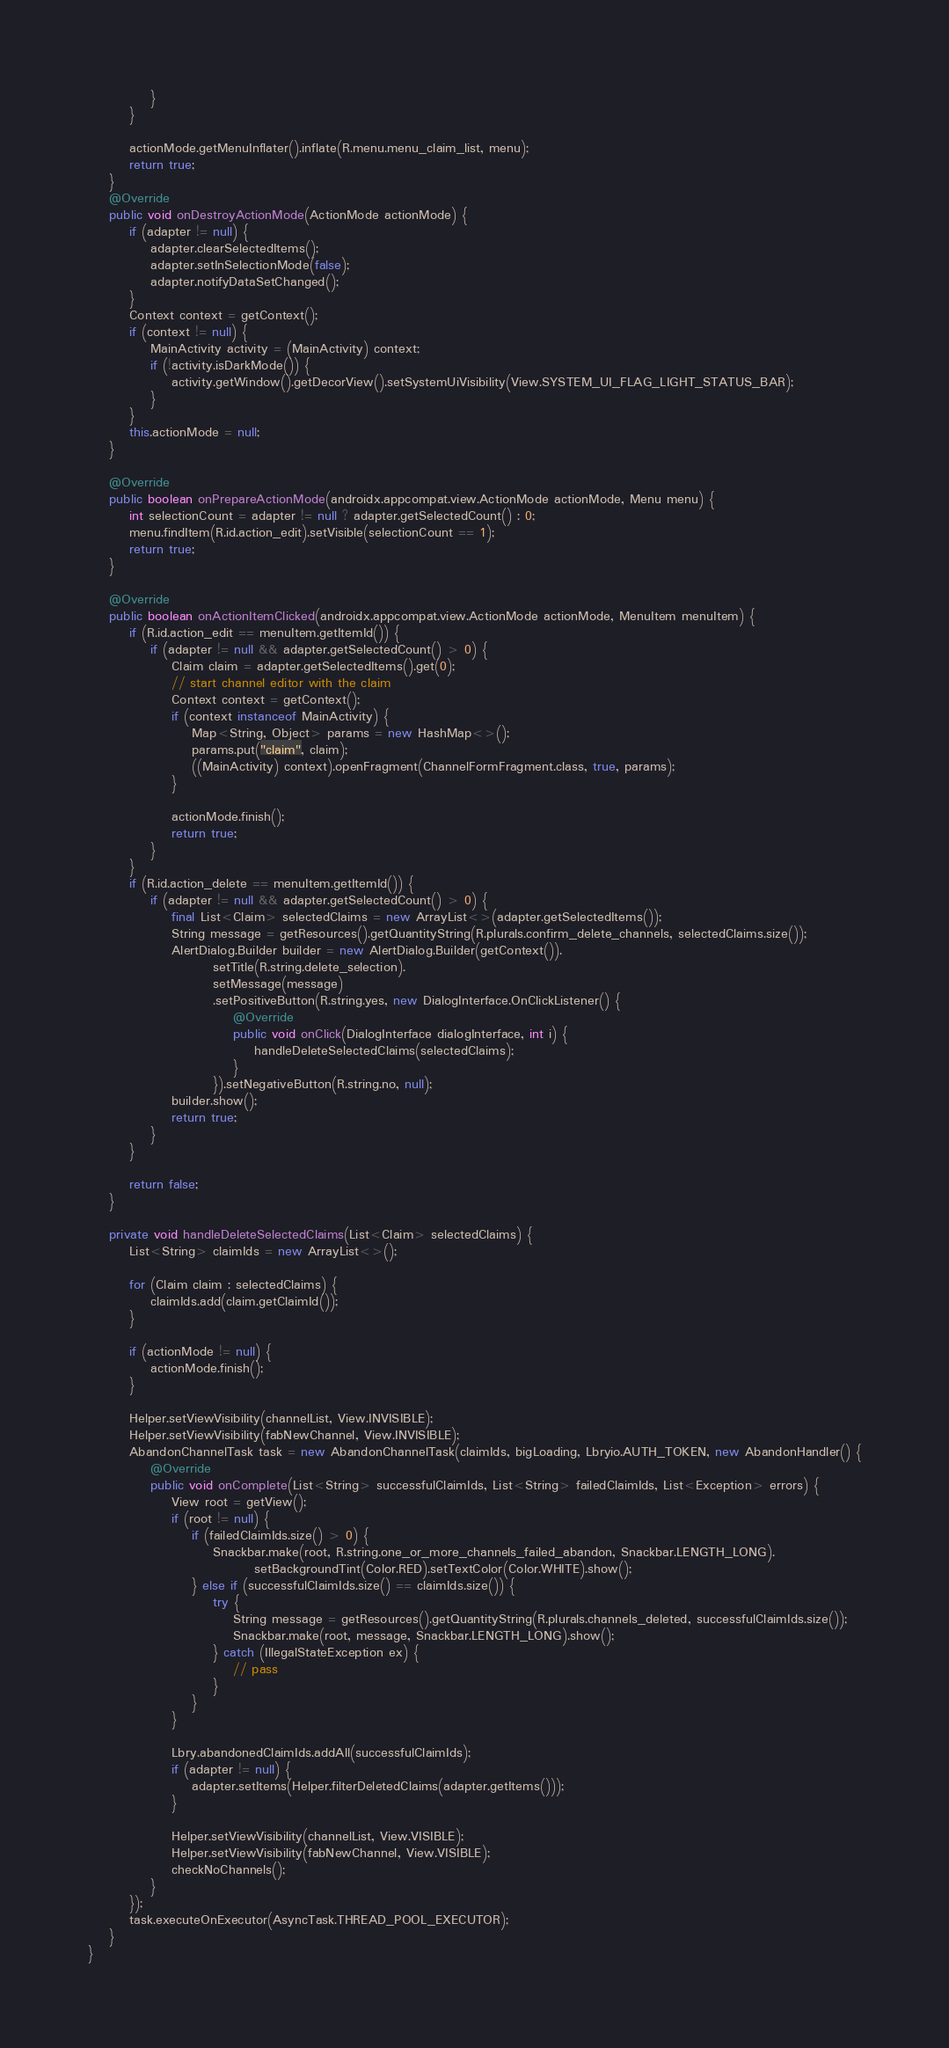<code> <loc_0><loc_0><loc_500><loc_500><_Java_>            }
        }

        actionMode.getMenuInflater().inflate(R.menu.menu_claim_list, menu);
        return true;
    }
    @Override
    public void onDestroyActionMode(ActionMode actionMode) {
        if (adapter != null) {
            adapter.clearSelectedItems();
            adapter.setInSelectionMode(false);
            adapter.notifyDataSetChanged();
        }
        Context context = getContext();
        if (context != null) {
            MainActivity activity = (MainActivity) context;
            if (!activity.isDarkMode()) {
                activity.getWindow().getDecorView().setSystemUiVisibility(View.SYSTEM_UI_FLAG_LIGHT_STATUS_BAR);
            }
        }
        this.actionMode = null;
    }

    @Override
    public boolean onPrepareActionMode(androidx.appcompat.view.ActionMode actionMode, Menu menu) {
        int selectionCount = adapter != null ? adapter.getSelectedCount() : 0;
        menu.findItem(R.id.action_edit).setVisible(selectionCount == 1);
        return true;
    }

    @Override
    public boolean onActionItemClicked(androidx.appcompat.view.ActionMode actionMode, MenuItem menuItem) {
        if (R.id.action_edit == menuItem.getItemId()) {
            if (adapter != null && adapter.getSelectedCount() > 0) {
                Claim claim = adapter.getSelectedItems().get(0);
                // start channel editor with the claim
                Context context = getContext();
                if (context instanceof MainActivity) {
                    Map<String, Object> params = new HashMap<>();
                    params.put("claim", claim);
                    ((MainActivity) context).openFragment(ChannelFormFragment.class, true, params);
                }

                actionMode.finish();
                return true;
            }
        }
        if (R.id.action_delete == menuItem.getItemId()) {
            if (adapter != null && adapter.getSelectedCount() > 0) {
                final List<Claim> selectedClaims = new ArrayList<>(adapter.getSelectedItems());
                String message = getResources().getQuantityString(R.plurals.confirm_delete_channels, selectedClaims.size());
                AlertDialog.Builder builder = new AlertDialog.Builder(getContext()).
                        setTitle(R.string.delete_selection).
                        setMessage(message)
                        .setPositiveButton(R.string.yes, new DialogInterface.OnClickListener() {
                            @Override
                            public void onClick(DialogInterface dialogInterface, int i) {
                                handleDeleteSelectedClaims(selectedClaims);
                            }
                        }).setNegativeButton(R.string.no, null);
                builder.show();
                return true;
            }
        }

        return false;
    }

    private void handleDeleteSelectedClaims(List<Claim> selectedClaims) {
        List<String> claimIds = new ArrayList<>();

        for (Claim claim : selectedClaims) {
            claimIds.add(claim.getClaimId());
        }

        if (actionMode != null) {
            actionMode.finish();
        }

        Helper.setViewVisibility(channelList, View.INVISIBLE);
        Helper.setViewVisibility(fabNewChannel, View.INVISIBLE);
        AbandonChannelTask task = new AbandonChannelTask(claimIds, bigLoading, Lbryio.AUTH_TOKEN, new AbandonHandler() {
            @Override
            public void onComplete(List<String> successfulClaimIds, List<String> failedClaimIds, List<Exception> errors) {
                View root = getView();
                if (root != null) {
                    if (failedClaimIds.size() > 0) {
                        Snackbar.make(root, R.string.one_or_more_channels_failed_abandon, Snackbar.LENGTH_LONG).
                                setBackgroundTint(Color.RED).setTextColor(Color.WHITE).show();
                    } else if (successfulClaimIds.size() == claimIds.size()) {
                        try {
                            String message = getResources().getQuantityString(R.plurals.channels_deleted, successfulClaimIds.size());
                            Snackbar.make(root, message, Snackbar.LENGTH_LONG).show();
                        } catch (IllegalStateException ex) {
                            // pass
                        }
                    }
                }

                Lbry.abandonedClaimIds.addAll(successfulClaimIds);
                if (adapter != null) {
                    adapter.setItems(Helper.filterDeletedClaims(adapter.getItems()));
                }

                Helper.setViewVisibility(channelList, View.VISIBLE);
                Helper.setViewVisibility(fabNewChannel, View.VISIBLE);
                checkNoChannels();
            }
        });
        task.executeOnExecutor(AsyncTask.THREAD_POOL_EXECUTOR);
    }
}
</code> 